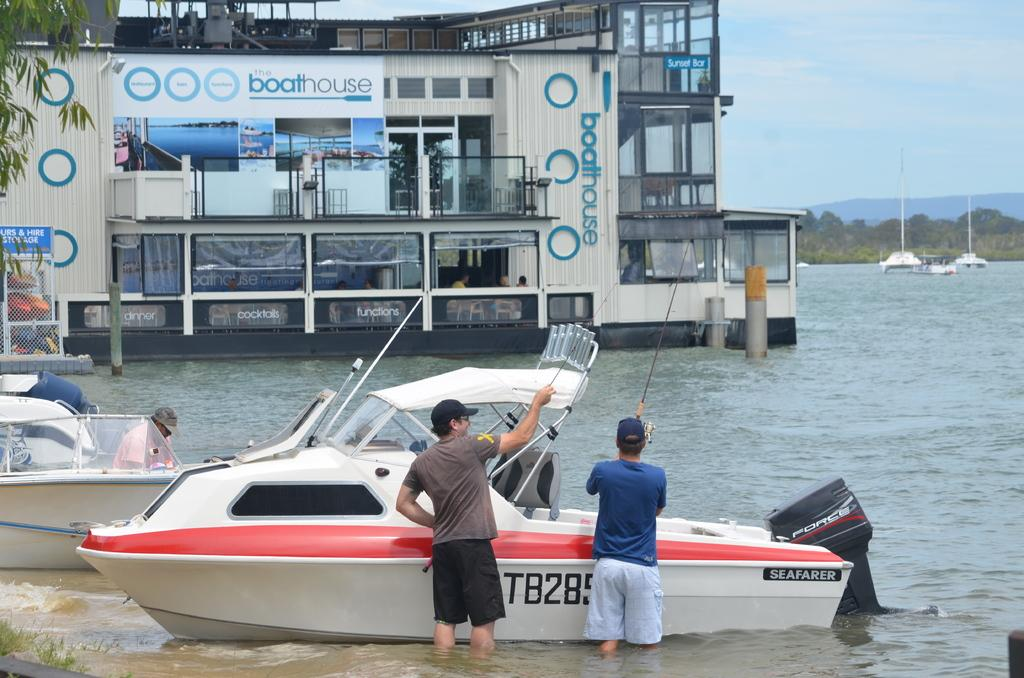What are the people in the image doing? The people in the image are in the water. What else can be seen on the water? There are boats on the water. What can be seen in the background of the image? There is a building, trees, mountains, and the sky visible in the background of the image. What type of rifle can be seen in the hands of the people in the image? There is no rifle present in the image; the people are in the water and there are boats on the water. 